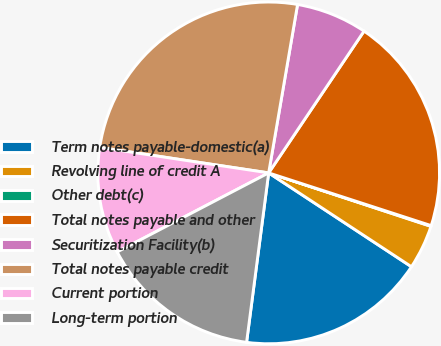<chart> <loc_0><loc_0><loc_500><loc_500><pie_chart><fcel>Term notes payable-domestic(a)<fcel>Revolving line of credit A<fcel>Other debt(c)<fcel>Total notes payable and other<fcel>Securitization Facility(b)<fcel>Total notes payable credit<fcel>Current portion<fcel>Long-term portion<nl><fcel>17.81%<fcel>4.19%<fcel>0.07%<fcel>20.57%<fcel>6.72%<fcel>25.32%<fcel>10.04%<fcel>15.28%<nl></chart> 